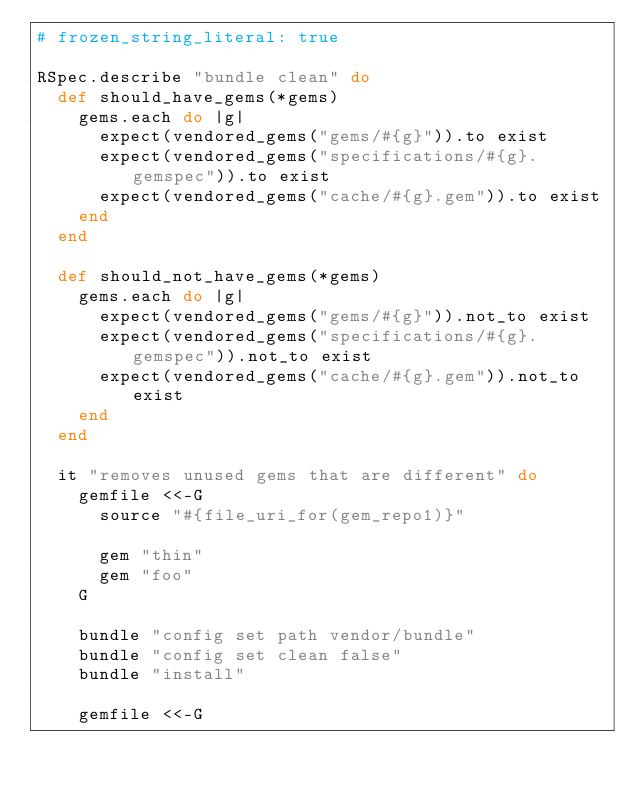Convert code to text. <code><loc_0><loc_0><loc_500><loc_500><_Ruby_># frozen_string_literal: true

RSpec.describe "bundle clean" do
  def should_have_gems(*gems)
    gems.each do |g|
      expect(vendored_gems("gems/#{g}")).to exist
      expect(vendored_gems("specifications/#{g}.gemspec")).to exist
      expect(vendored_gems("cache/#{g}.gem")).to exist
    end
  end

  def should_not_have_gems(*gems)
    gems.each do |g|
      expect(vendored_gems("gems/#{g}")).not_to exist
      expect(vendored_gems("specifications/#{g}.gemspec")).not_to exist
      expect(vendored_gems("cache/#{g}.gem")).not_to exist
    end
  end

  it "removes unused gems that are different" do
    gemfile <<-G
      source "#{file_uri_for(gem_repo1)}"

      gem "thin"
      gem "foo"
    G

    bundle "config set path vendor/bundle"
    bundle "config set clean false"
    bundle "install"

    gemfile <<-G</code> 